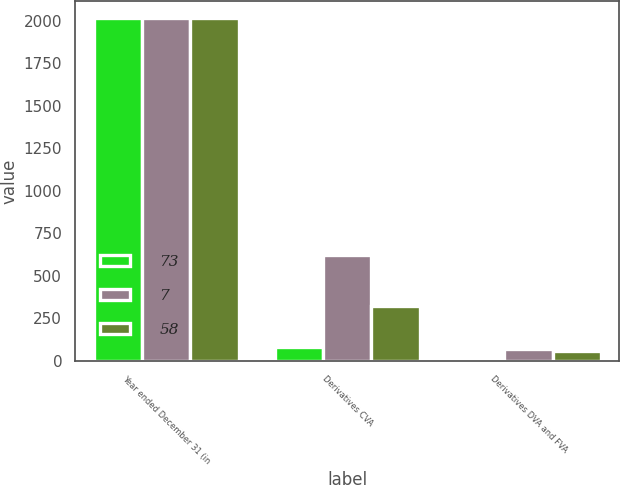Convert chart. <chart><loc_0><loc_0><loc_500><loc_500><stacked_bar_chart><ecel><fcel>Year ended December 31 (in<fcel>Derivatives CVA<fcel>Derivatives DVA and FVA<nl><fcel>73<fcel>2016<fcel>84<fcel>7<nl><fcel>7<fcel>2015<fcel>620<fcel>73<nl><fcel>58<fcel>2014<fcel>322<fcel>58<nl></chart> 